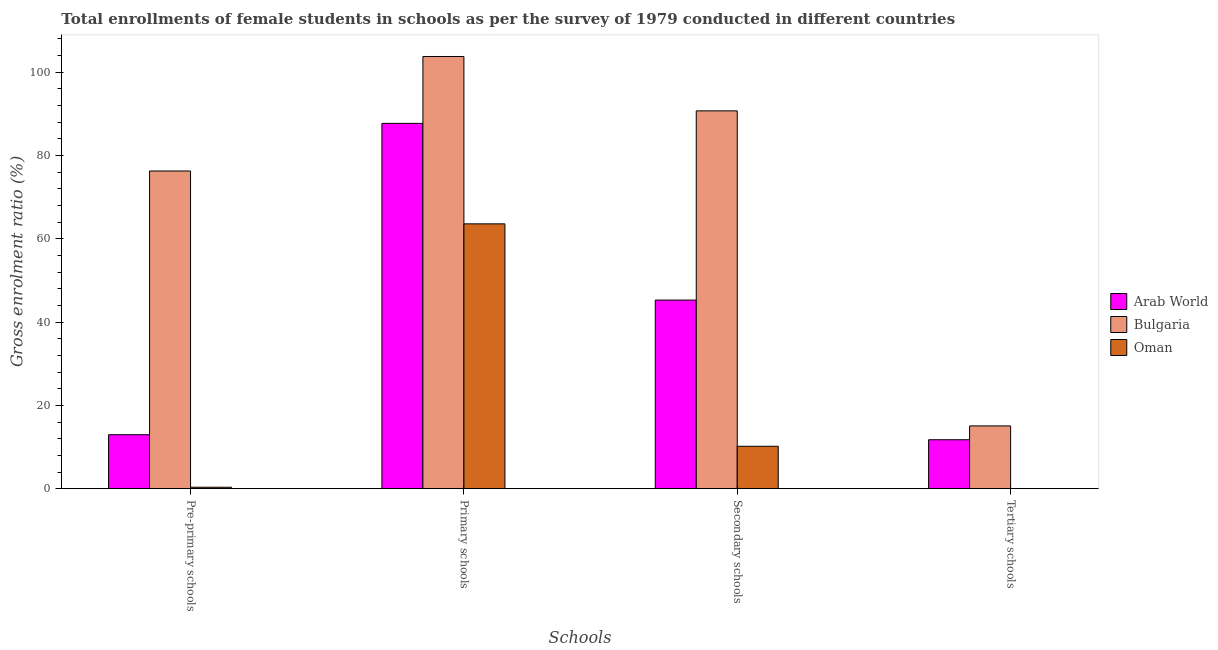Are the number of bars per tick equal to the number of legend labels?
Ensure brevity in your answer.  Yes. Are the number of bars on each tick of the X-axis equal?
Give a very brief answer. Yes. How many bars are there on the 1st tick from the left?
Your response must be concise. 3. What is the label of the 1st group of bars from the left?
Your answer should be very brief. Pre-primary schools. What is the gross enrolment ratio(female) in tertiary schools in Bulgaria?
Keep it short and to the point. 15.06. Across all countries, what is the maximum gross enrolment ratio(female) in primary schools?
Your response must be concise. 103.74. Across all countries, what is the minimum gross enrolment ratio(female) in secondary schools?
Provide a short and direct response. 10.18. In which country was the gross enrolment ratio(female) in pre-primary schools minimum?
Your answer should be compact. Oman. What is the total gross enrolment ratio(female) in secondary schools in the graph?
Your response must be concise. 146.13. What is the difference between the gross enrolment ratio(female) in pre-primary schools in Arab World and that in Bulgaria?
Provide a succinct answer. -63.3. What is the difference between the gross enrolment ratio(female) in tertiary schools in Arab World and the gross enrolment ratio(female) in secondary schools in Bulgaria?
Your answer should be compact. -78.94. What is the average gross enrolment ratio(female) in secondary schools per country?
Ensure brevity in your answer.  48.71. What is the difference between the gross enrolment ratio(female) in pre-primary schools and gross enrolment ratio(female) in tertiary schools in Arab World?
Give a very brief answer. 1.21. In how many countries, is the gross enrolment ratio(female) in pre-primary schools greater than 92 %?
Make the answer very short. 0. What is the ratio of the gross enrolment ratio(female) in primary schools in Arab World to that in Oman?
Your answer should be compact. 1.38. Is the gross enrolment ratio(female) in tertiary schools in Bulgaria less than that in Arab World?
Your answer should be compact. No. What is the difference between the highest and the second highest gross enrolment ratio(female) in primary schools?
Offer a very short reply. 16.06. What is the difference between the highest and the lowest gross enrolment ratio(female) in tertiary schools?
Your answer should be compact. 15.04. Is it the case that in every country, the sum of the gross enrolment ratio(female) in primary schools and gross enrolment ratio(female) in tertiary schools is greater than the sum of gross enrolment ratio(female) in secondary schools and gross enrolment ratio(female) in pre-primary schools?
Your response must be concise. Yes. What does the 1st bar from the right in Primary schools represents?
Offer a very short reply. Oman. Is it the case that in every country, the sum of the gross enrolment ratio(female) in pre-primary schools and gross enrolment ratio(female) in primary schools is greater than the gross enrolment ratio(female) in secondary schools?
Ensure brevity in your answer.  Yes. How many bars are there?
Make the answer very short. 12. How many countries are there in the graph?
Your answer should be very brief. 3. Are the values on the major ticks of Y-axis written in scientific E-notation?
Your answer should be compact. No. Does the graph contain grids?
Provide a short and direct response. No. Where does the legend appear in the graph?
Offer a terse response. Center right. What is the title of the graph?
Your response must be concise. Total enrollments of female students in schools as per the survey of 1979 conducted in different countries. What is the label or title of the X-axis?
Make the answer very short. Schools. What is the label or title of the Y-axis?
Make the answer very short. Gross enrolment ratio (%). What is the Gross enrolment ratio (%) of Arab World in Pre-primary schools?
Your response must be concise. 12.96. What is the Gross enrolment ratio (%) of Bulgaria in Pre-primary schools?
Provide a short and direct response. 76.26. What is the Gross enrolment ratio (%) in Oman in Pre-primary schools?
Provide a succinct answer. 0.34. What is the Gross enrolment ratio (%) of Arab World in Primary schools?
Make the answer very short. 87.68. What is the Gross enrolment ratio (%) of Bulgaria in Primary schools?
Provide a short and direct response. 103.74. What is the Gross enrolment ratio (%) in Oman in Primary schools?
Your response must be concise. 63.57. What is the Gross enrolment ratio (%) of Arab World in Secondary schools?
Your answer should be compact. 45.27. What is the Gross enrolment ratio (%) in Bulgaria in Secondary schools?
Your answer should be compact. 90.68. What is the Gross enrolment ratio (%) of Oman in Secondary schools?
Offer a terse response. 10.18. What is the Gross enrolment ratio (%) of Arab World in Tertiary schools?
Provide a short and direct response. 11.75. What is the Gross enrolment ratio (%) in Bulgaria in Tertiary schools?
Your answer should be compact. 15.06. What is the Gross enrolment ratio (%) in Oman in Tertiary schools?
Offer a very short reply. 0.02. Across all Schools, what is the maximum Gross enrolment ratio (%) in Arab World?
Provide a short and direct response. 87.68. Across all Schools, what is the maximum Gross enrolment ratio (%) of Bulgaria?
Your answer should be compact. 103.74. Across all Schools, what is the maximum Gross enrolment ratio (%) of Oman?
Offer a terse response. 63.57. Across all Schools, what is the minimum Gross enrolment ratio (%) in Arab World?
Offer a terse response. 11.75. Across all Schools, what is the minimum Gross enrolment ratio (%) in Bulgaria?
Your answer should be very brief. 15.06. Across all Schools, what is the minimum Gross enrolment ratio (%) of Oman?
Offer a very short reply. 0.02. What is the total Gross enrolment ratio (%) of Arab World in the graph?
Make the answer very short. 157.66. What is the total Gross enrolment ratio (%) in Bulgaria in the graph?
Your response must be concise. 285.74. What is the total Gross enrolment ratio (%) in Oman in the graph?
Give a very brief answer. 74.11. What is the difference between the Gross enrolment ratio (%) in Arab World in Pre-primary schools and that in Primary schools?
Your answer should be very brief. -74.73. What is the difference between the Gross enrolment ratio (%) of Bulgaria in Pre-primary schools and that in Primary schools?
Give a very brief answer. -27.48. What is the difference between the Gross enrolment ratio (%) of Oman in Pre-primary schools and that in Primary schools?
Offer a terse response. -63.22. What is the difference between the Gross enrolment ratio (%) in Arab World in Pre-primary schools and that in Secondary schools?
Make the answer very short. -32.31. What is the difference between the Gross enrolment ratio (%) in Bulgaria in Pre-primary schools and that in Secondary schools?
Offer a terse response. -14.43. What is the difference between the Gross enrolment ratio (%) in Oman in Pre-primary schools and that in Secondary schools?
Provide a short and direct response. -9.84. What is the difference between the Gross enrolment ratio (%) of Arab World in Pre-primary schools and that in Tertiary schools?
Your answer should be very brief. 1.21. What is the difference between the Gross enrolment ratio (%) of Bulgaria in Pre-primary schools and that in Tertiary schools?
Ensure brevity in your answer.  61.19. What is the difference between the Gross enrolment ratio (%) in Oman in Pre-primary schools and that in Tertiary schools?
Offer a terse response. 0.32. What is the difference between the Gross enrolment ratio (%) of Arab World in Primary schools and that in Secondary schools?
Your answer should be compact. 42.41. What is the difference between the Gross enrolment ratio (%) in Bulgaria in Primary schools and that in Secondary schools?
Your answer should be very brief. 13.06. What is the difference between the Gross enrolment ratio (%) in Oman in Primary schools and that in Secondary schools?
Give a very brief answer. 53.39. What is the difference between the Gross enrolment ratio (%) in Arab World in Primary schools and that in Tertiary schools?
Give a very brief answer. 75.94. What is the difference between the Gross enrolment ratio (%) of Bulgaria in Primary schools and that in Tertiary schools?
Give a very brief answer. 88.68. What is the difference between the Gross enrolment ratio (%) of Oman in Primary schools and that in Tertiary schools?
Give a very brief answer. 63.54. What is the difference between the Gross enrolment ratio (%) of Arab World in Secondary schools and that in Tertiary schools?
Provide a succinct answer. 33.52. What is the difference between the Gross enrolment ratio (%) of Bulgaria in Secondary schools and that in Tertiary schools?
Your answer should be very brief. 75.62. What is the difference between the Gross enrolment ratio (%) in Oman in Secondary schools and that in Tertiary schools?
Give a very brief answer. 10.15. What is the difference between the Gross enrolment ratio (%) in Arab World in Pre-primary schools and the Gross enrolment ratio (%) in Bulgaria in Primary schools?
Keep it short and to the point. -90.78. What is the difference between the Gross enrolment ratio (%) in Arab World in Pre-primary schools and the Gross enrolment ratio (%) in Oman in Primary schools?
Give a very brief answer. -50.61. What is the difference between the Gross enrolment ratio (%) in Bulgaria in Pre-primary schools and the Gross enrolment ratio (%) in Oman in Primary schools?
Make the answer very short. 12.69. What is the difference between the Gross enrolment ratio (%) of Arab World in Pre-primary schools and the Gross enrolment ratio (%) of Bulgaria in Secondary schools?
Your answer should be compact. -77.73. What is the difference between the Gross enrolment ratio (%) in Arab World in Pre-primary schools and the Gross enrolment ratio (%) in Oman in Secondary schools?
Offer a very short reply. 2.78. What is the difference between the Gross enrolment ratio (%) in Bulgaria in Pre-primary schools and the Gross enrolment ratio (%) in Oman in Secondary schools?
Provide a short and direct response. 66.08. What is the difference between the Gross enrolment ratio (%) of Arab World in Pre-primary schools and the Gross enrolment ratio (%) of Bulgaria in Tertiary schools?
Keep it short and to the point. -2.11. What is the difference between the Gross enrolment ratio (%) of Arab World in Pre-primary schools and the Gross enrolment ratio (%) of Oman in Tertiary schools?
Offer a very short reply. 12.94. What is the difference between the Gross enrolment ratio (%) of Bulgaria in Pre-primary schools and the Gross enrolment ratio (%) of Oman in Tertiary schools?
Your response must be concise. 76.23. What is the difference between the Gross enrolment ratio (%) of Arab World in Primary schools and the Gross enrolment ratio (%) of Bulgaria in Secondary schools?
Offer a very short reply. -3. What is the difference between the Gross enrolment ratio (%) of Arab World in Primary schools and the Gross enrolment ratio (%) of Oman in Secondary schools?
Offer a terse response. 77.51. What is the difference between the Gross enrolment ratio (%) in Bulgaria in Primary schools and the Gross enrolment ratio (%) in Oman in Secondary schools?
Ensure brevity in your answer.  93.56. What is the difference between the Gross enrolment ratio (%) of Arab World in Primary schools and the Gross enrolment ratio (%) of Bulgaria in Tertiary schools?
Offer a very short reply. 72.62. What is the difference between the Gross enrolment ratio (%) of Arab World in Primary schools and the Gross enrolment ratio (%) of Oman in Tertiary schools?
Ensure brevity in your answer.  87.66. What is the difference between the Gross enrolment ratio (%) in Bulgaria in Primary schools and the Gross enrolment ratio (%) in Oman in Tertiary schools?
Your answer should be compact. 103.72. What is the difference between the Gross enrolment ratio (%) in Arab World in Secondary schools and the Gross enrolment ratio (%) in Bulgaria in Tertiary schools?
Your answer should be compact. 30.21. What is the difference between the Gross enrolment ratio (%) in Arab World in Secondary schools and the Gross enrolment ratio (%) in Oman in Tertiary schools?
Provide a succinct answer. 45.25. What is the difference between the Gross enrolment ratio (%) in Bulgaria in Secondary schools and the Gross enrolment ratio (%) in Oman in Tertiary schools?
Provide a short and direct response. 90.66. What is the average Gross enrolment ratio (%) in Arab World per Schools?
Your answer should be very brief. 39.41. What is the average Gross enrolment ratio (%) in Bulgaria per Schools?
Your response must be concise. 71.44. What is the average Gross enrolment ratio (%) of Oman per Schools?
Give a very brief answer. 18.53. What is the difference between the Gross enrolment ratio (%) in Arab World and Gross enrolment ratio (%) in Bulgaria in Pre-primary schools?
Provide a short and direct response. -63.3. What is the difference between the Gross enrolment ratio (%) in Arab World and Gross enrolment ratio (%) in Oman in Pre-primary schools?
Offer a terse response. 12.62. What is the difference between the Gross enrolment ratio (%) in Bulgaria and Gross enrolment ratio (%) in Oman in Pre-primary schools?
Make the answer very short. 75.91. What is the difference between the Gross enrolment ratio (%) in Arab World and Gross enrolment ratio (%) in Bulgaria in Primary schools?
Make the answer very short. -16.06. What is the difference between the Gross enrolment ratio (%) of Arab World and Gross enrolment ratio (%) of Oman in Primary schools?
Your answer should be compact. 24.12. What is the difference between the Gross enrolment ratio (%) of Bulgaria and Gross enrolment ratio (%) of Oman in Primary schools?
Provide a succinct answer. 40.17. What is the difference between the Gross enrolment ratio (%) of Arab World and Gross enrolment ratio (%) of Bulgaria in Secondary schools?
Your answer should be compact. -45.41. What is the difference between the Gross enrolment ratio (%) in Arab World and Gross enrolment ratio (%) in Oman in Secondary schools?
Your answer should be very brief. 35.09. What is the difference between the Gross enrolment ratio (%) in Bulgaria and Gross enrolment ratio (%) in Oman in Secondary schools?
Offer a very short reply. 80.51. What is the difference between the Gross enrolment ratio (%) in Arab World and Gross enrolment ratio (%) in Bulgaria in Tertiary schools?
Your response must be concise. -3.32. What is the difference between the Gross enrolment ratio (%) of Arab World and Gross enrolment ratio (%) of Oman in Tertiary schools?
Provide a short and direct response. 11.72. What is the difference between the Gross enrolment ratio (%) of Bulgaria and Gross enrolment ratio (%) of Oman in Tertiary schools?
Offer a very short reply. 15.04. What is the ratio of the Gross enrolment ratio (%) of Arab World in Pre-primary schools to that in Primary schools?
Offer a terse response. 0.15. What is the ratio of the Gross enrolment ratio (%) in Bulgaria in Pre-primary schools to that in Primary schools?
Keep it short and to the point. 0.74. What is the ratio of the Gross enrolment ratio (%) in Oman in Pre-primary schools to that in Primary schools?
Your answer should be compact. 0.01. What is the ratio of the Gross enrolment ratio (%) in Arab World in Pre-primary schools to that in Secondary schools?
Your answer should be compact. 0.29. What is the ratio of the Gross enrolment ratio (%) in Bulgaria in Pre-primary schools to that in Secondary schools?
Keep it short and to the point. 0.84. What is the ratio of the Gross enrolment ratio (%) in Oman in Pre-primary schools to that in Secondary schools?
Provide a short and direct response. 0.03. What is the ratio of the Gross enrolment ratio (%) of Arab World in Pre-primary schools to that in Tertiary schools?
Your answer should be compact. 1.1. What is the ratio of the Gross enrolment ratio (%) in Bulgaria in Pre-primary schools to that in Tertiary schools?
Keep it short and to the point. 5.06. What is the ratio of the Gross enrolment ratio (%) in Oman in Pre-primary schools to that in Tertiary schools?
Your answer should be very brief. 15.06. What is the ratio of the Gross enrolment ratio (%) of Arab World in Primary schools to that in Secondary schools?
Offer a very short reply. 1.94. What is the ratio of the Gross enrolment ratio (%) of Bulgaria in Primary schools to that in Secondary schools?
Your answer should be very brief. 1.14. What is the ratio of the Gross enrolment ratio (%) of Oman in Primary schools to that in Secondary schools?
Keep it short and to the point. 6.25. What is the ratio of the Gross enrolment ratio (%) in Arab World in Primary schools to that in Tertiary schools?
Your answer should be very brief. 7.46. What is the ratio of the Gross enrolment ratio (%) of Bulgaria in Primary schools to that in Tertiary schools?
Give a very brief answer. 6.89. What is the ratio of the Gross enrolment ratio (%) of Oman in Primary schools to that in Tertiary schools?
Offer a very short reply. 2791.67. What is the ratio of the Gross enrolment ratio (%) of Arab World in Secondary schools to that in Tertiary schools?
Make the answer very short. 3.85. What is the ratio of the Gross enrolment ratio (%) in Bulgaria in Secondary schools to that in Tertiary schools?
Give a very brief answer. 6.02. What is the ratio of the Gross enrolment ratio (%) in Oman in Secondary schools to that in Tertiary schools?
Your answer should be very brief. 446.98. What is the difference between the highest and the second highest Gross enrolment ratio (%) of Arab World?
Keep it short and to the point. 42.41. What is the difference between the highest and the second highest Gross enrolment ratio (%) of Bulgaria?
Provide a succinct answer. 13.06. What is the difference between the highest and the second highest Gross enrolment ratio (%) in Oman?
Offer a terse response. 53.39. What is the difference between the highest and the lowest Gross enrolment ratio (%) in Arab World?
Provide a short and direct response. 75.94. What is the difference between the highest and the lowest Gross enrolment ratio (%) in Bulgaria?
Keep it short and to the point. 88.68. What is the difference between the highest and the lowest Gross enrolment ratio (%) of Oman?
Keep it short and to the point. 63.54. 